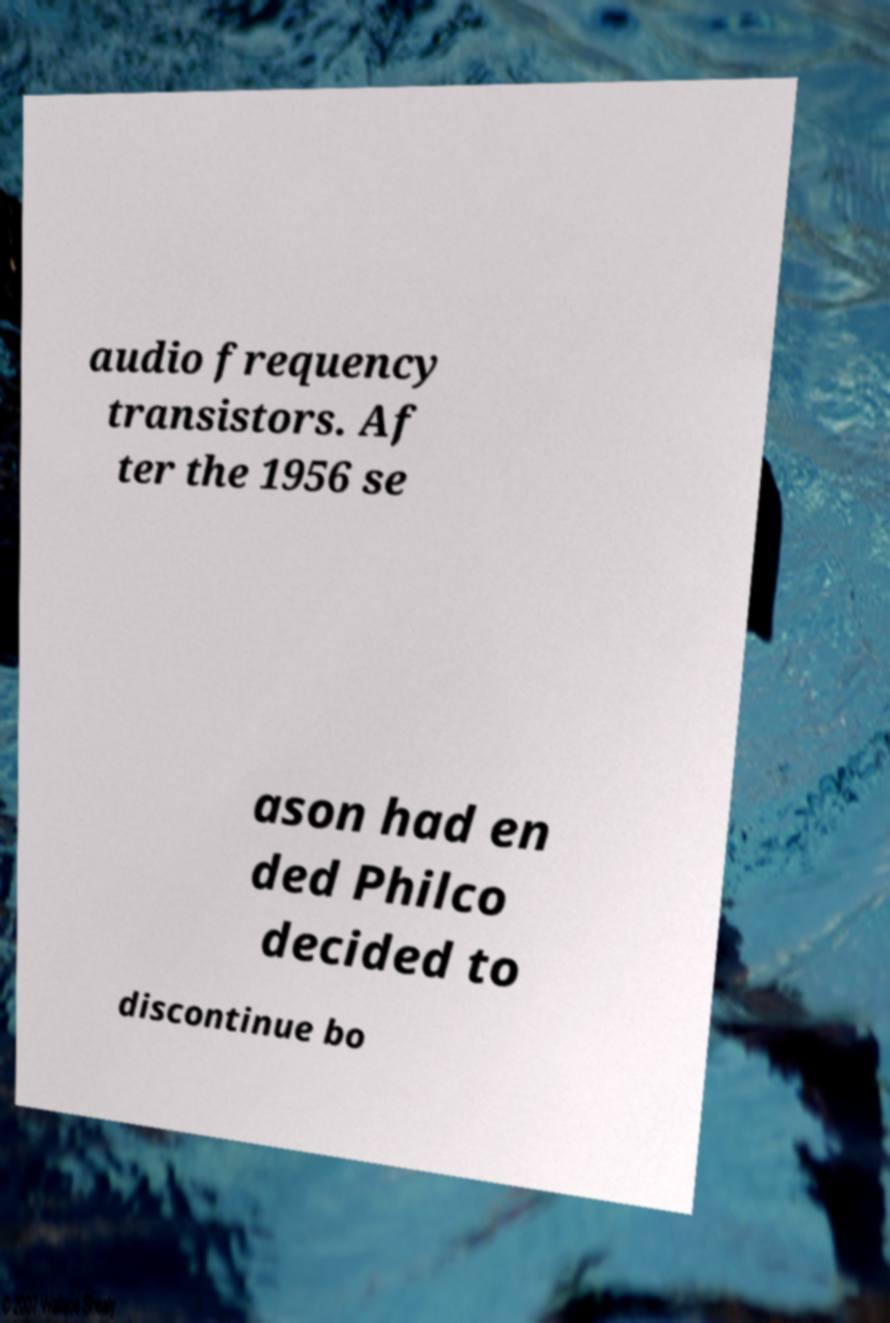Can you read and provide the text displayed in the image?This photo seems to have some interesting text. Can you extract and type it out for me? audio frequency transistors. Af ter the 1956 se ason had en ded Philco decided to discontinue bo 